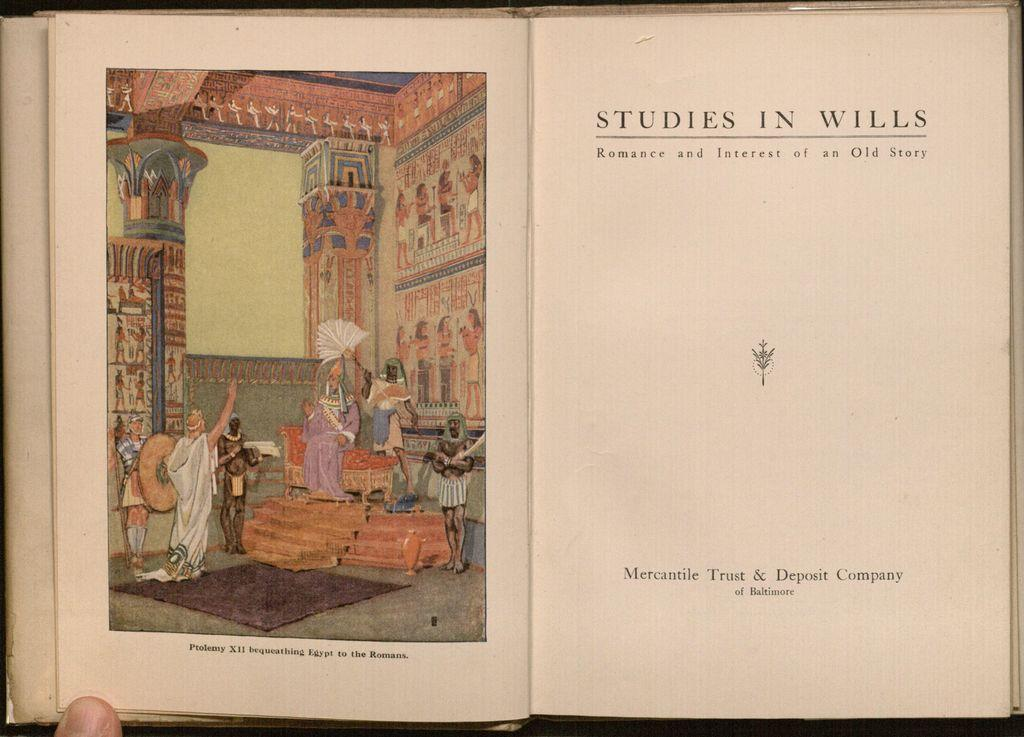Provide a one-sentence caption for the provided image. Studies in wills romance and interest of an Old story chapter book. 